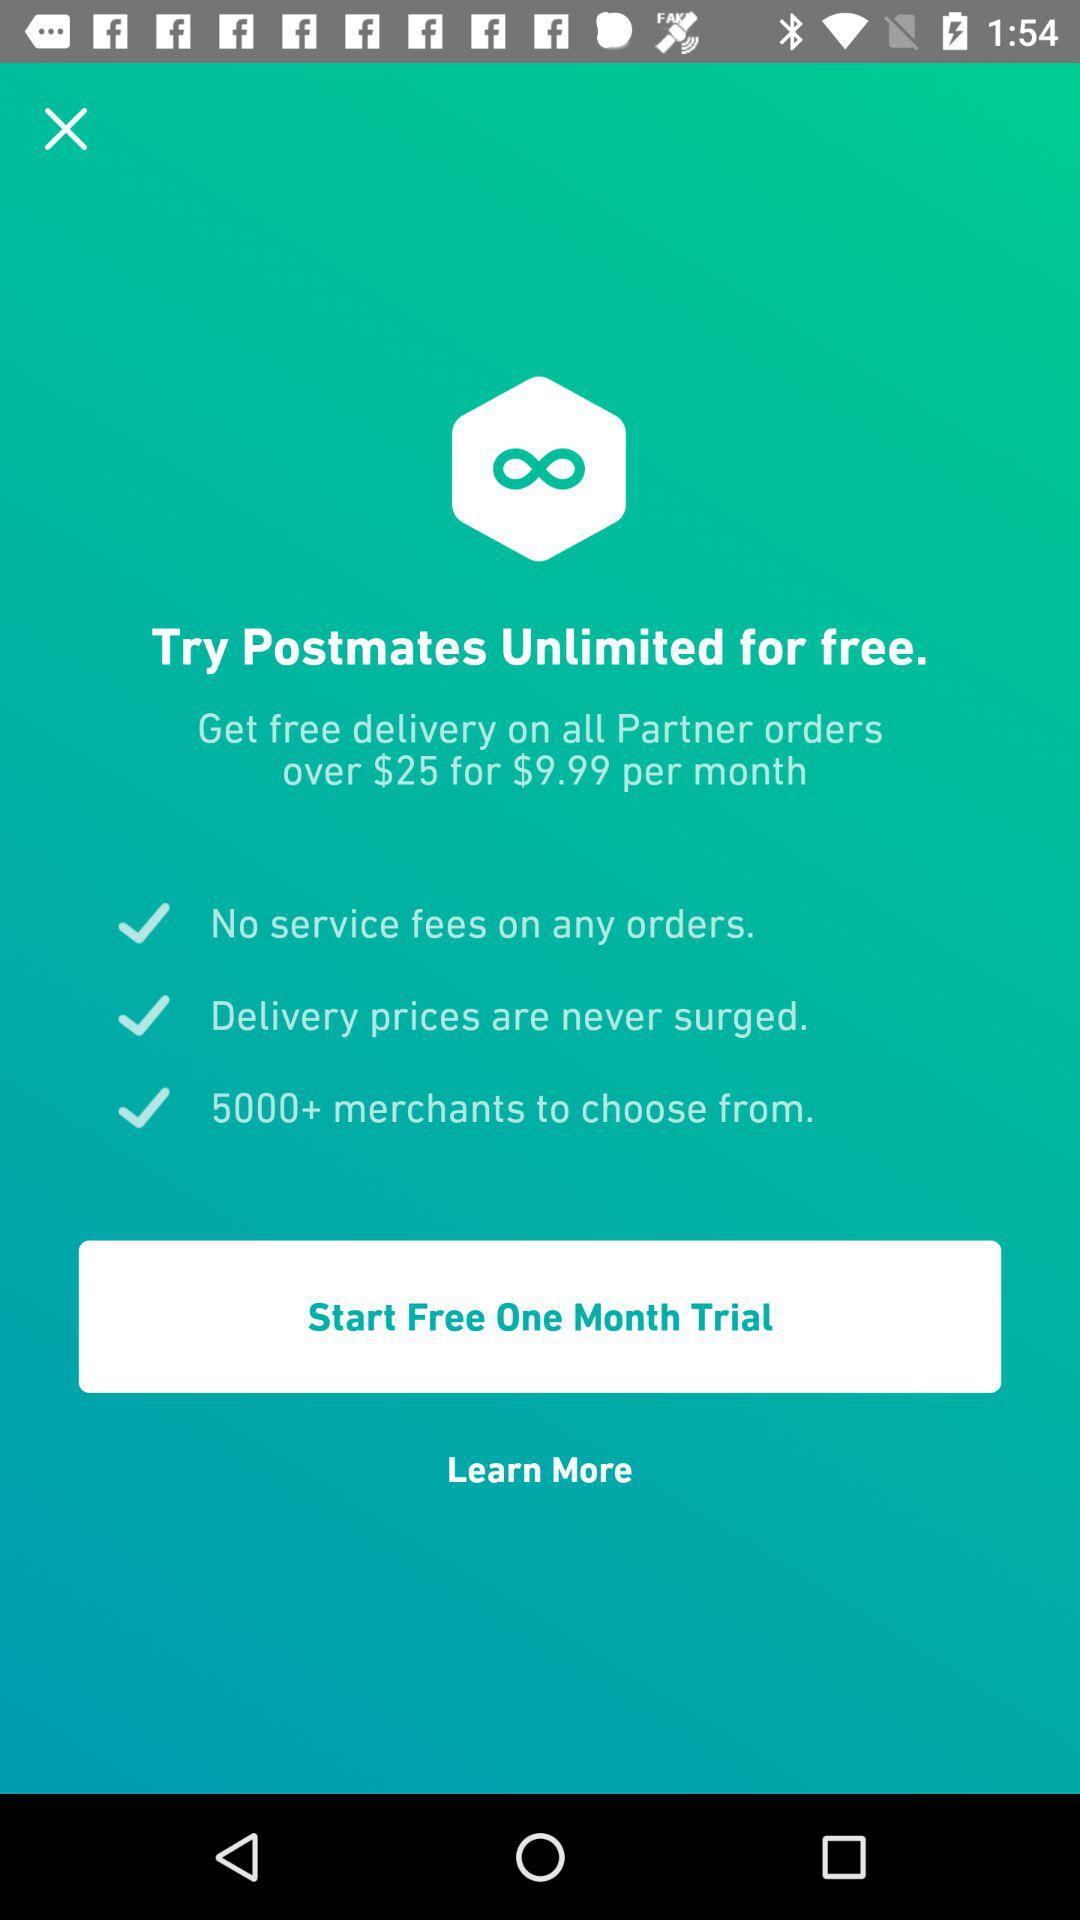What is the cost per month? The cost per month is $9.99. 